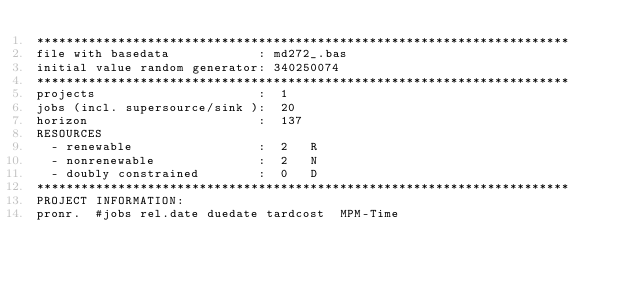<code> <loc_0><loc_0><loc_500><loc_500><_ObjectiveC_>************************************************************************
file with basedata            : md272_.bas
initial value random generator: 340250074
************************************************************************
projects                      :  1
jobs (incl. supersource/sink ):  20
horizon                       :  137
RESOURCES
  - renewable                 :  2   R
  - nonrenewable              :  2   N
  - doubly constrained        :  0   D
************************************************************************
PROJECT INFORMATION:
pronr.  #jobs rel.date duedate tardcost  MPM-Time</code> 